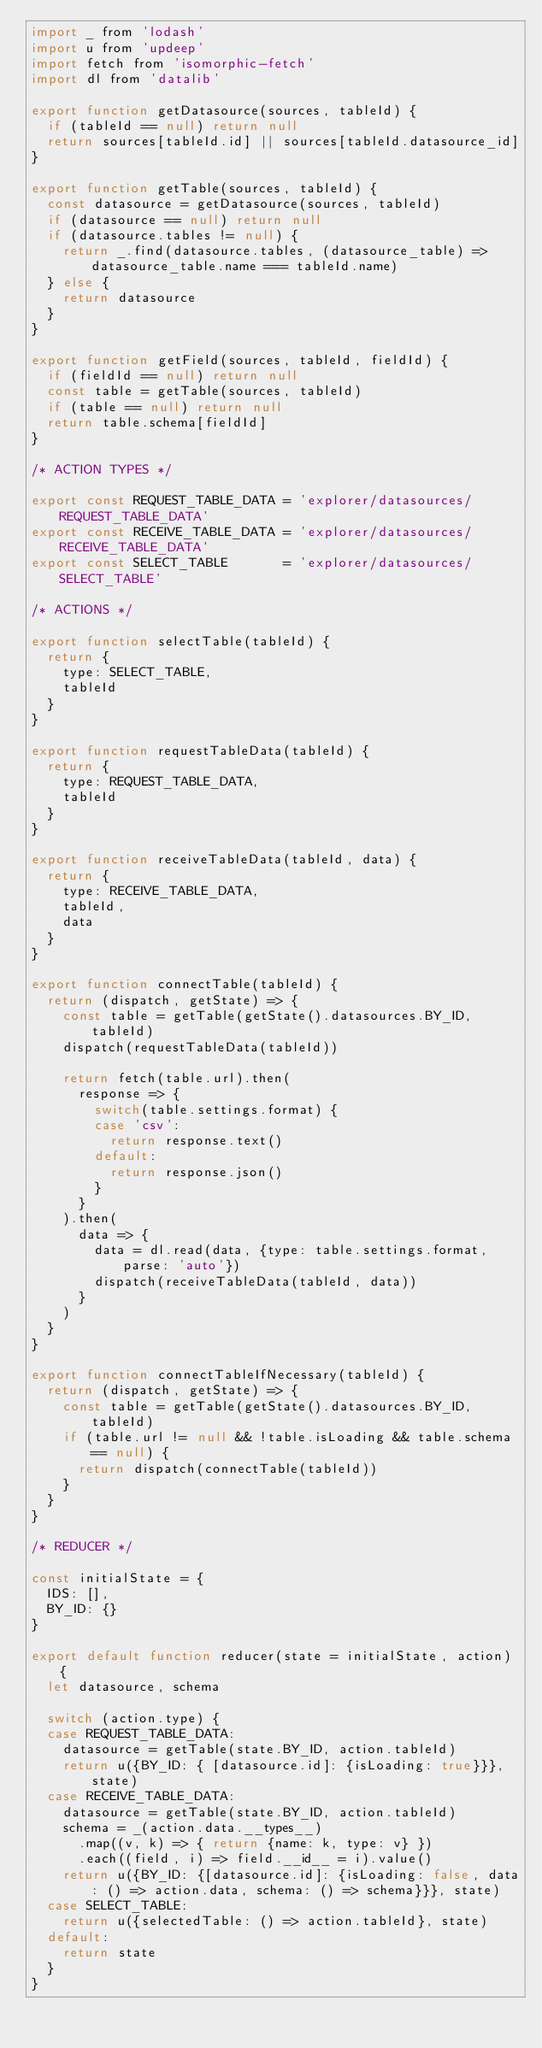Convert code to text. <code><loc_0><loc_0><loc_500><loc_500><_JavaScript_>import _ from 'lodash'
import u from 'updeep'
import fetch from 'isomorphic-fetch'
import dl from 'datalib'

export function getDatasource(sources, tableId) {
  if (tableId == null) return null
  return sources[tableId.id] || sources[tableId.datasource_id]
}

export function getTable(sources, tableId) {
  const datasource = getDatasource(sources, tableId)
  if (datasource == null) return null
  if (datasource.tables != null) {
    return _.find(datasource.tables, (datasource_table) => datasource_table.name === tableId.name)
  } else {
    return datasource
  }
}

export function getField(sources, tableId, fieldId) {
  if (fieldId == null) return null
  const table = getTable(sources, tableId)
  if (table == null) return null
  return table.schema[fieldId]
}

/* ACTION TYPES */

export const REQUEST_TABLE_DATA = 'explorer/datasources/REQUEST_TABLE_DATA'
export const RECEIVE_TABLE_DATA = 'explorer/datasources/RECEIVE_TABLE_DATA'
export const SELECT_TABLE       = 'explorer/datasources/SELECT_TABLE'

/* ACTIONS */

export function selectTable(tableId) {
  return {
    type: SELECT_TABLE,
    tableId
  }
}

export function requestTableData(tableId) {
  return {
    type: REQUEST_TABLE_DATA,
    tableId
  }
}

export function receiveTableData(tableId, data) {
  return {
    type: RECEIVE_TABLE_DATA,
    tableId,
    data
  }
}

export function connectTable(tableId) {
  return (dispatch, getState) => {
    const table = getTable(getState().datasources.BY_ID, tableId)
    dispatch(requestTableData(tableId))

    return fetch(table.url).then(
      response => {
        switch(table.settings.format) {
        case 'csv':
          return response.text()
        default:
          return response.json()
        }
      }
    ).then(
      data => {
        data = dl.read(data, {type: table.settings.format, parse: 'auto'})
        dispatch(receiveTableData(tableId, data))
      }
    )
  }
}

export function connectTableIfNecessary(tableId) {
  return (dispatch, getState) => {
    const table = getTable(getState().datasources.BY_ID, tableId)
    if (table.url != null && !table.isLoading && table.schema == null) {
      return dispatch(connectTable(tableId))
    }
  }
}

/* REDUCER */

const initialState = {
  IDS: [],
  BY_ID: {}
}

export default function reducer(state = initialState, action) {
  let datasource, schema

  switch (action.type) {
  case REQUEST_TABLE_DATA:
    datasource = getTable(state.BY_ID, action.tableId)
    return u({BY_ID: { [datasource.id]: {isLoading: true}}}, state)
  case RECEIVE_TABLE_DATA:
    datasource = getTable(state.BY_ID, action.tableId)
    schema = _(action.data.__types__)
      .map((v, k) => { return {name: k, type: v} })
      .each((field, i) => field.__id__ = i).value()
    return u({BY_ID: {[datasource.id]: {isLoading: false, data: () => action.data, schema: () => schema}}}, state)
  case SELECT_TABLE:
    return u({selectedTable: () => action.tableId}, state)
  default:
    return state
  }
}
</code> 